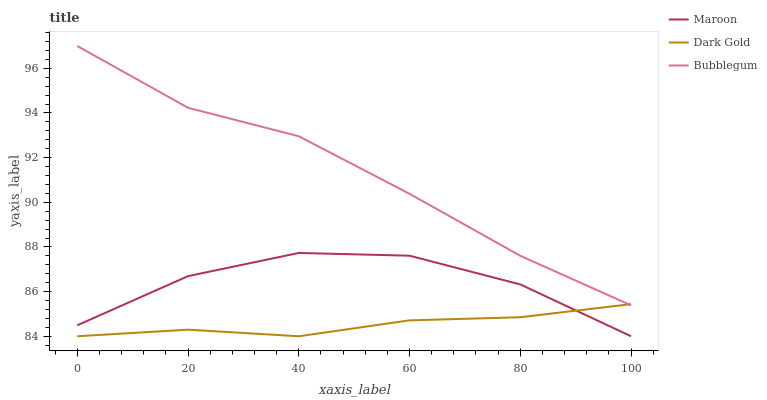Does Dark Gold have the minimum area under the curve?
Answer yes or no. Yes. Does Bubblegum have the maximum area under the curve?
Answer yes or no. Yes. Does Maroon have the minimum area under the curve?
Answer yes or no. No. Does Maroon have the maximum area under the curve?
Answer yes or no. No. Is Dark Gold the smoothest?
Answer yes or no. Yes. Is Maroon the roughest?
Answer yes or no. Yes. Is Maroon the smoothest?
Answer yes or no. No. Is Dark Gold the roughest?
Answer yes or no. No. Does Maroon have the lowest value?
Answer yes or no. Yes. Does Bubblegum have the highest value?
Answer yes or no. Yes. Does Maroon have the highest value?
Answer yes or no. No. Is Maroon less than Bubblegum?
Answer yes or no. Yes. Is Bubblegum greater than Maroon?
Answer yes or no. Yes. Does Maroon intersect Dark Gold?
Answer yes or no. Yes. Is Maroon less than Dark Gold?
Answer yes or no. No. Is Maroon greater than Dark Gold?
Answer yes or no. No. Does Maroon intersect Bubblegum?
Answer yes or no. No. 